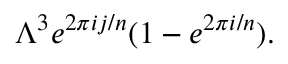Convert formula to latex. <formula><loc_0><loc_0><loc_500><loc_500>\Lambda ^ { 3 } e ^ { 2 \pi i j / n } ( 1 - e ^ { 2 \pi i / n } ) .</formula> 